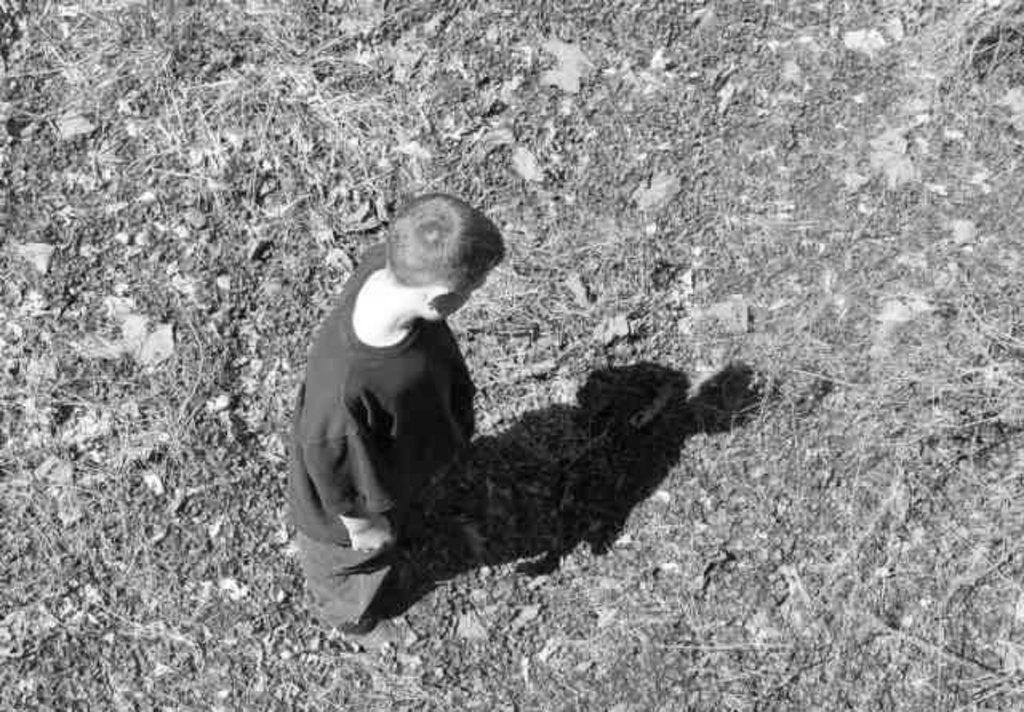In one or two sentences, can you explain what this image depicts? In this image there is one person who is standing, and at the bottom there are some dry leaves and grass. 